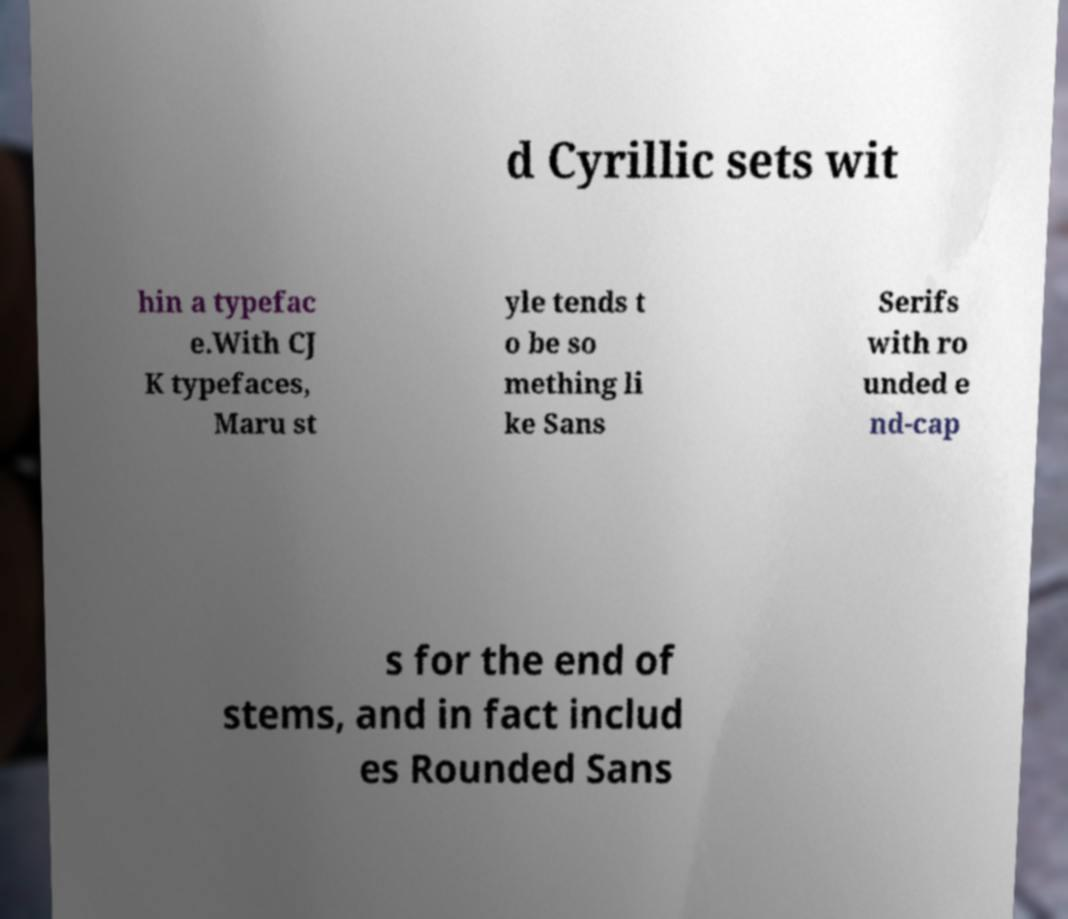Can you read and provide the text displayed in the image?This photo seems to have some interesting text. Can you extract and type it out for me? d Cyrillic sets wit hin a typefac e.With CJ K typefaces, Maru st yle tends t o be so mething li ke Sans Serifs with ro unded e nd-cap s for the end of stems, and in fact includ es Rounded Sans 